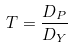Convert formula to latex. <formula><loc_0><loc_0><loc_500><loc_500>T = \frac { D _ { P } } { D _ { Y } }</formula> 